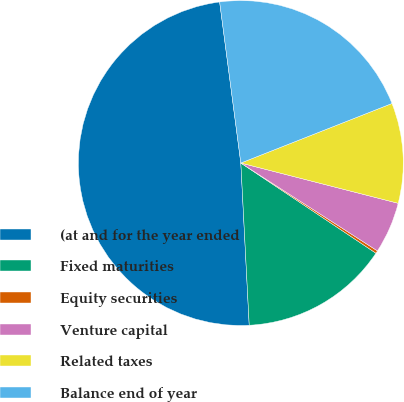<chart> <loc_0><loc_0><loc_500><loc_500><pie_chart><fcel>(at and for the year ended<fcel>Fixed maturities<fcel>Equity securities<fcel>Venture capital<fcel>Related taxes<fcel>Balance end of year<nl><fcel>48.74%<fcel>14.81%<fcel>0.27%<fcel>5.11%<fcel>9.96%<fcel>21.11%<nl></chart> 